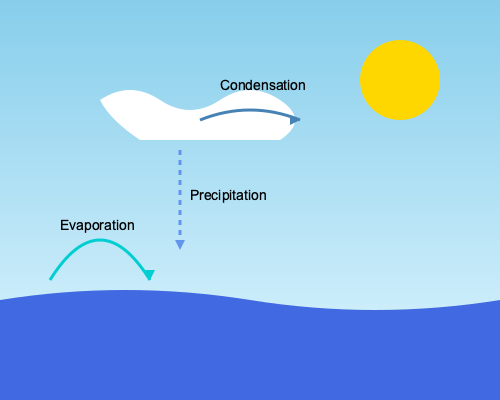As an environmental scientist, you're studying the water cycle in a coastal ecosystem. The diagram illustrates the three main processes of the water cycle. If the rate of evaporation is 5 mm/day and the rate of precipitation is 3 mm/day, what is the net water flux (in mm/day) between the ocean and atmosphere, and in which direction is it occurring? To solve this problem, let's follow these steps:

1. Identify the processes:
   - Evaporation: Water moving from the ocean to the atmosphere
   - Condensation: Water vapor forming clouds in the atmosphere
   - Precipitation: Water returning from the atmosphere to the ocean

2. Analyze the given rates:
   - Evaporation rate = 5 mm/day (ocean to atmosphere)
   - Precipitation rate = 3 mm/day (atmosphere to ocean)

3. Calculate the net water flux:
   - Net flux = Evaporation - Precipitation
   - Net flux = 5 mm/day - 3 mm/day = 2 mm/day

4. Determine the direction:
   - The net flux is positive, meaning more water is moving from the ocean to the atmosphere than vice versa.

5. Interpret the result:
   - The net water flux is 2 mm/day from the ocean to the atmosphere.

This net flux indicates that in this coastal ecosystem, there is a net loss of water from the ocean to the atmosphere, which could have implications for local climate, salinity levels, and ecosystem dynamics.
Answer: 2 mm/day, ocean to atmosphere 